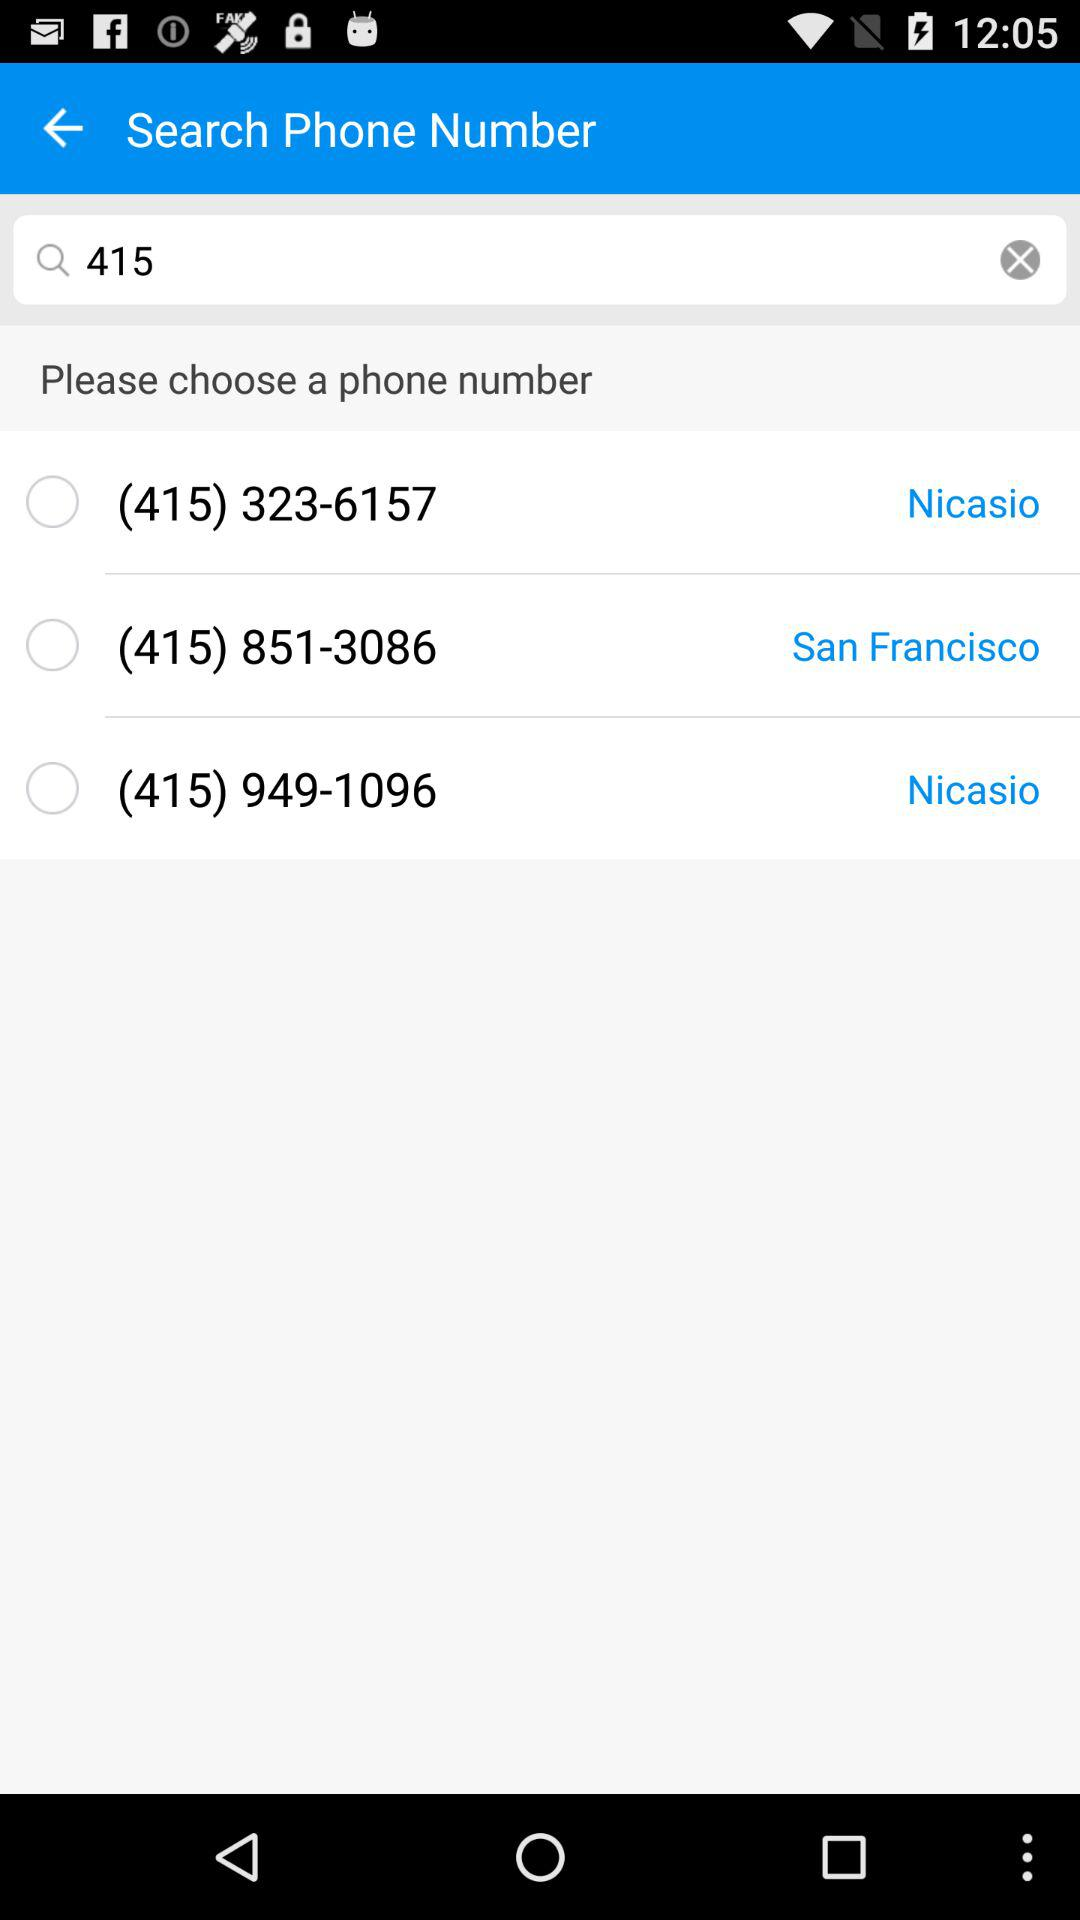What is the phone number for San Francisco? The phone number for San Francisco is (415) 851-3086. 